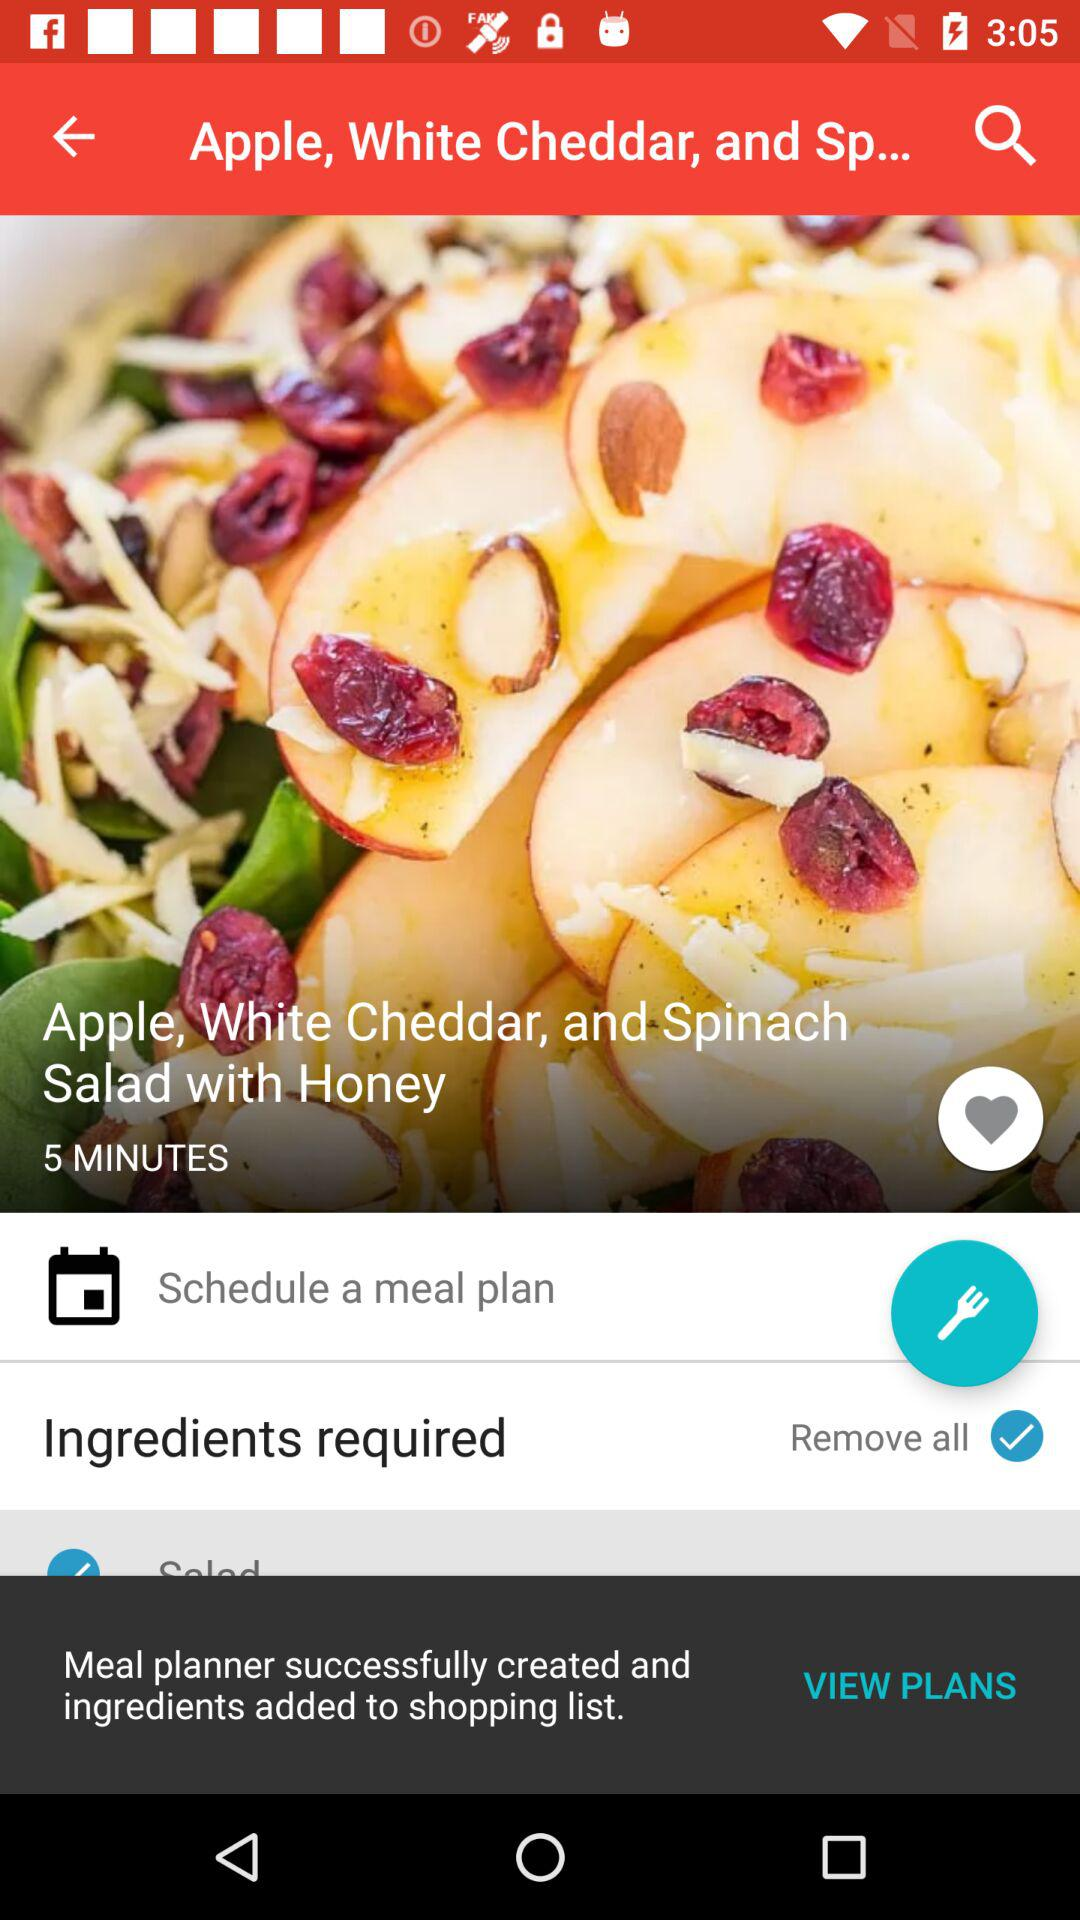What is the dish's name? The dish's name is "Apple, White Cheddar, and Spinach Salad with Honey". 